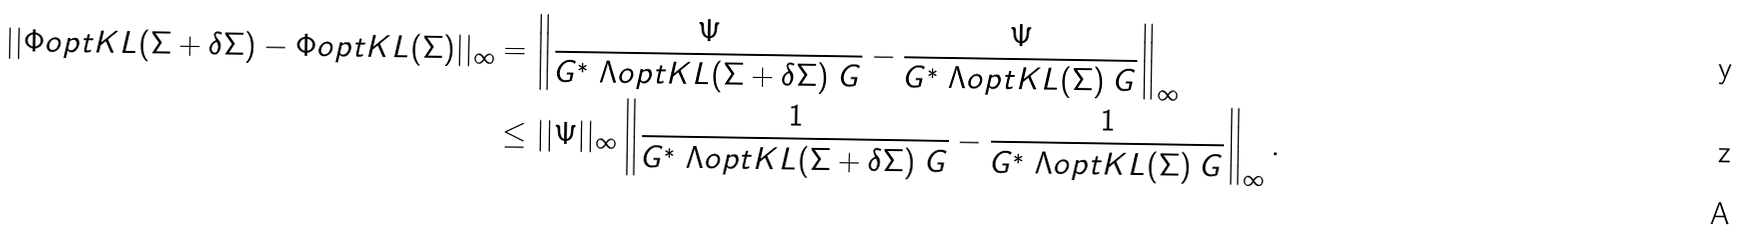<formula> <loc_0><loc_0><loc_500><loc_500>| | \Phi o p t K L ( \Sigma + \delta \Sigma ) - \Phi o p t K L ( \Sigma ) | | _ { \infty } & = \left \| \frac { \Psi } { G ^ { \ast } \ \Lambda o p t K L ( \Sigma + \delta \Sigma ) \ G } - \frac { \Psi } { G ^ { \ast } \ \Lambda o p t K L ( \Sigma ) \ G } \right \| _ { \infty } \\ & \leq | | \Psi | | _ { \infty } \left \| \frac { 1 } { G ^ { \ast } \ \Lambda o p t K L ( \Sigma + \delta \Sigma ) \ G } - \frac { 1 } { G ^ { \ast } \ \Lambda o p t K L ( \Sigma ) \ G } \right \| _ { \infty } . \\</formula> 